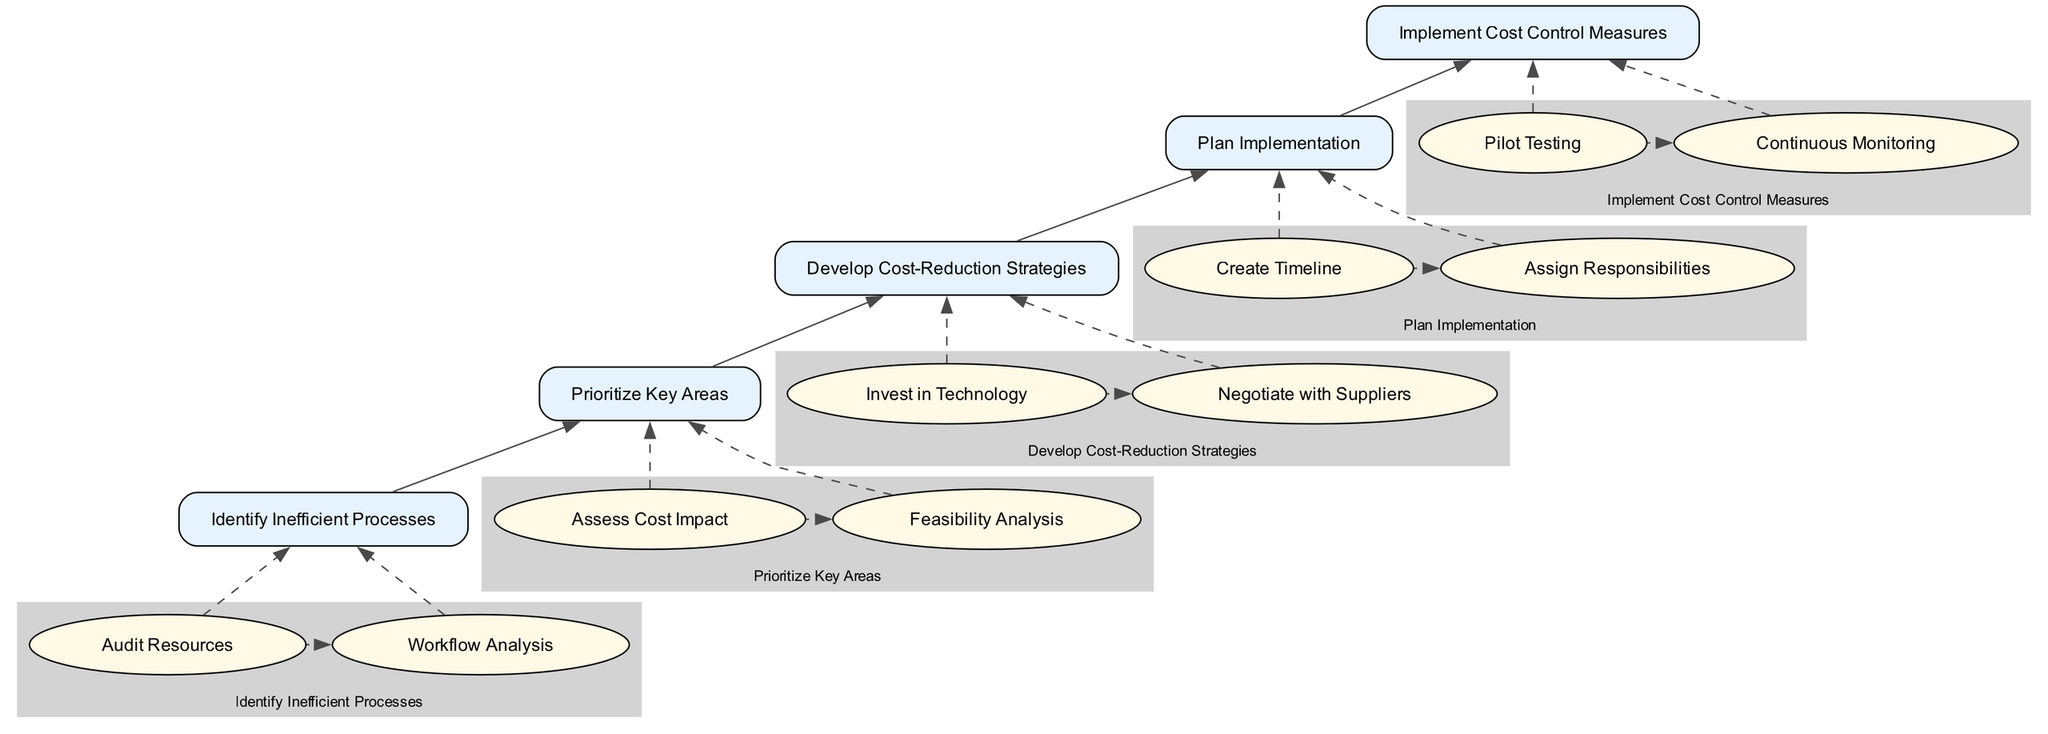What is the first step in the flowchart? The first step identified in the flowchart is "Identify Inefficient Processes," which is located at the bottom of the diagram. This is based on the flow moving from bottom to top, starting with identifying inefficiencies.
Answer: Identify Inefficient Processes How many main elements are present in this flowchart? The flowchart consists of five main elements, which are connected sequentially from the bottom up, highlighting different strategies for reducing operational costs.
Answer: Five Which step comes after "Audit Resources"? After "Audit Resources," the next step is "Workflow Analysis," as indicated by the flow from "Audit Resources" leading directly to "Workflow Analysis" within the same main element.
Answer: Workflow Analysis What is the relationship between "Negotiate with Suppliers" and "Develop Cost-Reduction Strategies"? "Negotiate with Suppliers" is a sub-step under "Develop Cost-Reduction Strategies," indicating that it is part of the strategies that are being developed to address inefficiencies identified earlier in the process.
Answer: Sub-step Which two cost control measures require monitoring? The two measures requiring monitoring are "Pilot Testing" and "Continuous Monitoring," both of which indicate actions that must be assessed over time to ensure effectiveness post-implementation.
Answer: Pilot Testing, Continuous Monitoring What must be created before implementing cost control measures? A "Plan Implementation" must be created before implementing the cost control measures, as it outlines the strategy and provides a structured timeline before execution.
Answer: Plan Implementation In which step is the feasibility of changes analyzed? The feasibility of changes is analyzed in the "Feasibility Analysis" step, which is a sub-step of "Prioritize Key Areas," highlighting that we assess practicality before proceeding.
Answer: Feasibility Analysis What follows directly after "Assess Cost Impact"? "Feasibility Analysis" follows directly after "Assess Cost Impact," indicating the sequence in which these critical evaluation steps are taken in the process.
Answer: Feasibility Analysis Which step is the final output of the flowchart? The final output of the flowchart is "Implement Cost Control Measures," representing the culmination of all previous strategies leading to the execution of cost-saving measures.
Answer: Implement Cost Control Measures 